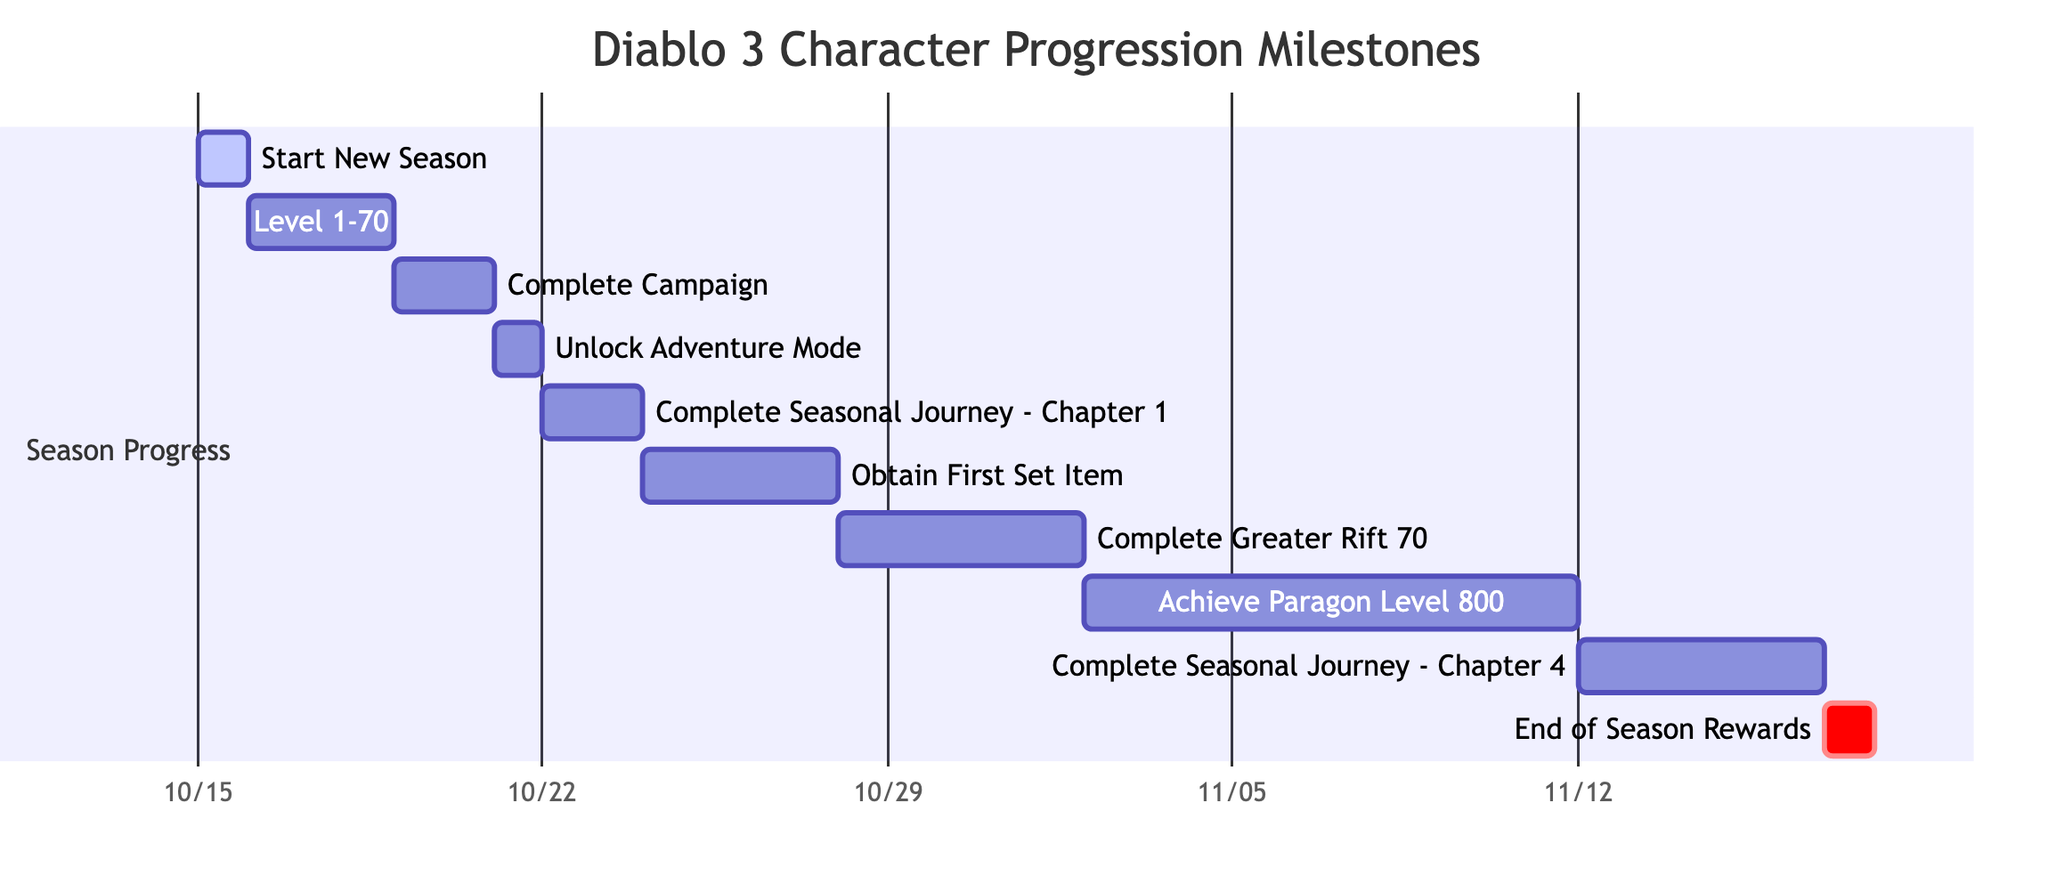What task starts on October 15, 2023? The first task listed in the Gantt chart is "Start New Season," which starts on October 15, 2023.
Answer: Start New Season How long does it take to achieve Paragon Level 800? Looking at the timeline for the task "Achieve Paragon Level 800," it spans 10 days, starting on November 2, 2023, and ending on November 11, 2023.
Answer: 10 days What task follows after completing the campaign? The task that follows "Complete Campaign" is "Unlock Adventure Mode," which starts right after the campaign is completed on October 21, 2023.
Answer: Unlock Adventure Mode How many days does it take to complete the Seasonal Journey - Chapter 4? The task "Complete Seasonal Journey - Chapter 4" has a duration of 5 days, starting November 12, 2023, and ending November 16, 2023.
Answer: 5 days What is the end date for obtaining the First Set Item? The task "Obtain First Set Item" ends on October 27, 2023, based on its duration of 4 days starting from October 24, 2023.
Answer: October 27, 2023 How many tasks are there in total? By counting all the tasks listed in the Gantt chart, there are a total of 10 tasks, including starting the new season and ending with the end of season rewards.
Answer: 10 tasks Which task has the longest duration in the chart? The task with the longest duration is "Achieve Paragon Level 800," which lasts for 10 days, making it the longest task in the Gantt chart.
Answer: Achieve Paragon Level 800 When do the End of Season Rewards take place? According to the Gantt chart, the "End of Season Rewards" takes place on November 17, 2023, with a duration of 1 day.
Answer: November 17, 2023 What comes directly after the "Complete Greater Rift 70" task? Following the task "Complete Greater Rift 70," the next task is "Achieve Paragon Level 800," which begins immediately after the Greater Rift task is finished.
Answer: Achieve Paragon Level 800 